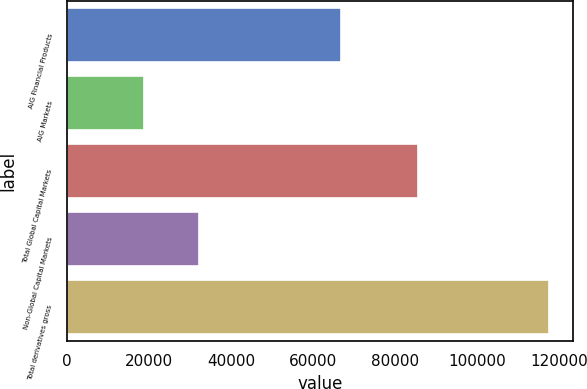Convert chart to OTSL. <chart><loc_0><loc_0><loc_500><loc_500><bar_chart><fcel>AIG Financial Products<fcel>AIG Markets<fcel>Total Global Capital Markets<fcel>Non-Global Capital Markets<fcel>Total derivatives gross<nl><fcel>66717<fcel>18774<fcel>85491<fcel>32139<fcel>117630<nl></chart> 